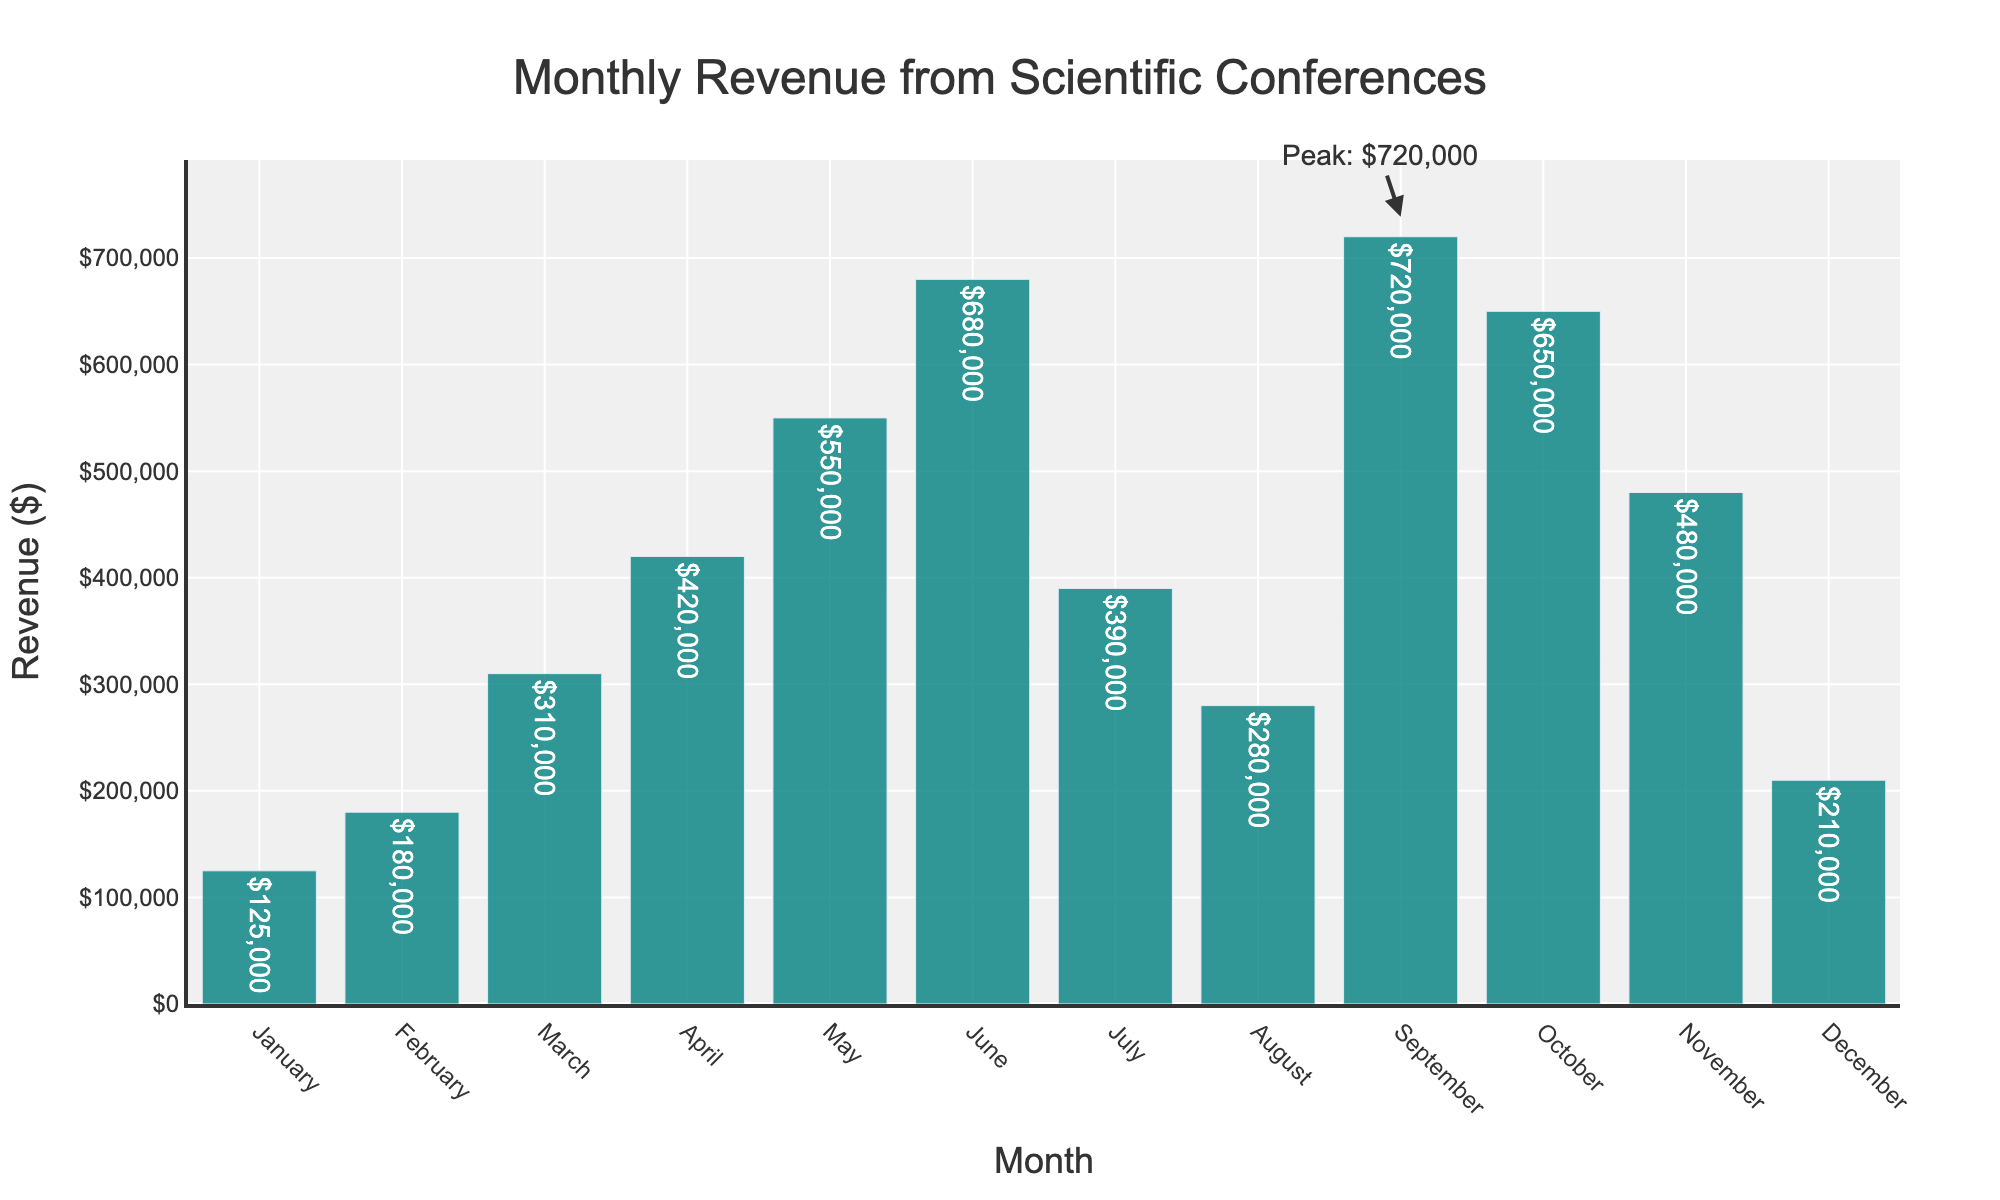What is the peak revenue month? The peak revenue month is the one with the highest bar and the annotation indicating the peak revenue, which is September.
Answer: September Which month had the lowest revenue? The lowest revenue is indicated by the shortest bar. January has the shortest bar.
Answer: January How much more revenue was generated in June compared to August? The revenue for June is $680,000 and for August is $280,000. The difference is $680,000 - $280,000.
Answer: $400,000 Were there any months with exactly the same revenue? By visually inspecting the height of the bars, no two months have bars of exactly the same height.
Answer: No How does the revenue in October compare to April? The bar for October is slightly lower than the bar for April. The revenue in October is $650,000 and in April is $420,000.
Answer: October has higher revenue What is the total revenue generated in the first quarter (January to March)? Sum the revenue for January ($125,000), February ($180,000), and March ($310,000). The total is $125,000 + $180,000 + $310,000 = $615,000.
Answer: $615,000 Which quarter had the highest total revenue? Sum the revenues by quarter: 
Q1: $125,000 + $180,000 + $310,000 = $615,000 
Q2: $420,000 + $550,000 + $680,000 = $1,650,000 
Q3: $390,000 + $280,000 + $720,000 = $1,390,000 
Q4: $650,000 + $480,000 + $210,000 = $1,340,000 
Q2 has the highest total revenue.
Answer: Q2 What is the average monthly revenue for the entire year? Sum all the monthly revenues and divide by 12. 
Total revenue = $125,000 + $180,000 + $310,000 + $420,000 + $550,000 + $680,000 + $390,000 + $280,000 + $720,000 + $650,000 + $480,000 + $210,000 = $4,995,000 
Average monthly revenue = $4,995,000 / 12 = $416,250.
Answer: $416,250 In which months did the revenue exceed $500,000? Identify the months where the bar height corresponds to revenue over $500,000: May ($550,000), June ($680,000), September ($720,000), October ($650,000).
Answer: May, June, September, October Is July's revenue higher or lower than the average monthly revenue? The average monthly revenue is $416,250. July's revenue is $390,000. July's revenue is lower than the average.
Answer: Lower 